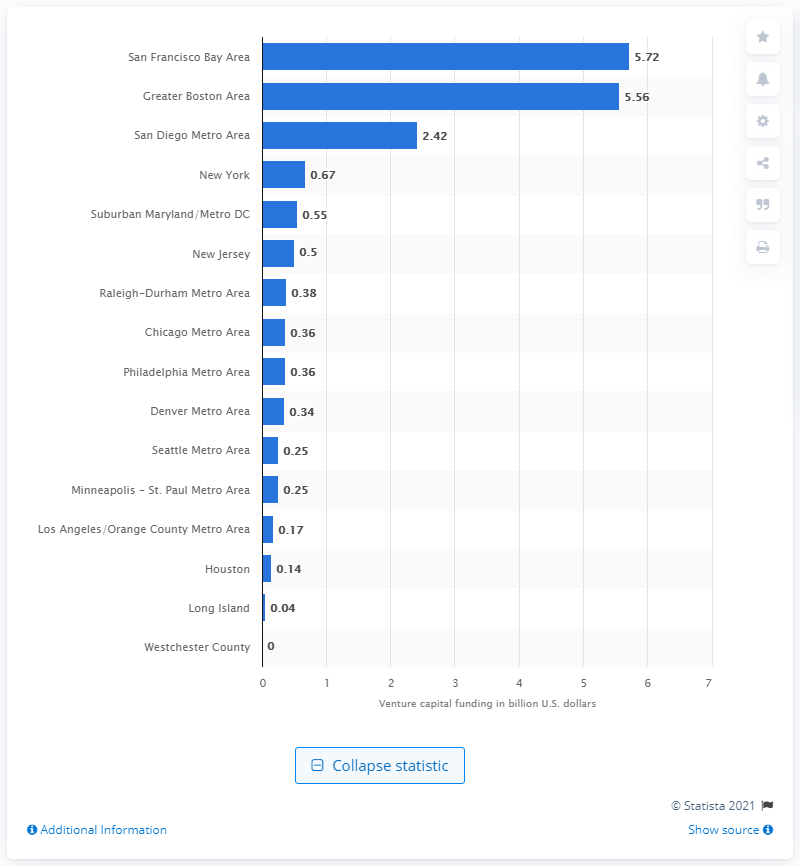Point out several critical features in this image. The Raleigh-Durham Metro Area received $0.38 billion in venture capital funding in 2018. 